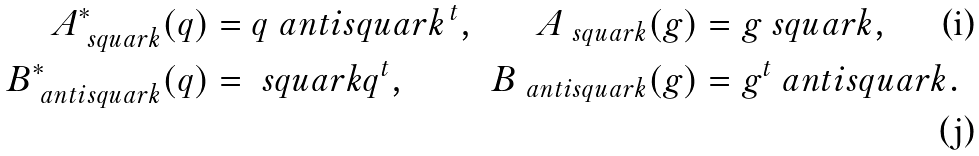<formula> <loc_0><loc_0><loc_500><loc_500>A ^ { * } _ { \ s q u a r k } ( q ) & = q \ a n t i s q u a r k ^ { \, t } , & A _ { \ s q u a r k } ( g ) & = g \ s q u a r k , \\ B ^ { * } _ { \ a n t i s q u a r k } ( q ) & = \ s q u a r k q ^ { t } , & B _ { \ a n t i s q u a r k } ( g ) & = g ^ { t } \ a n t i s q u a r k .</formula> 